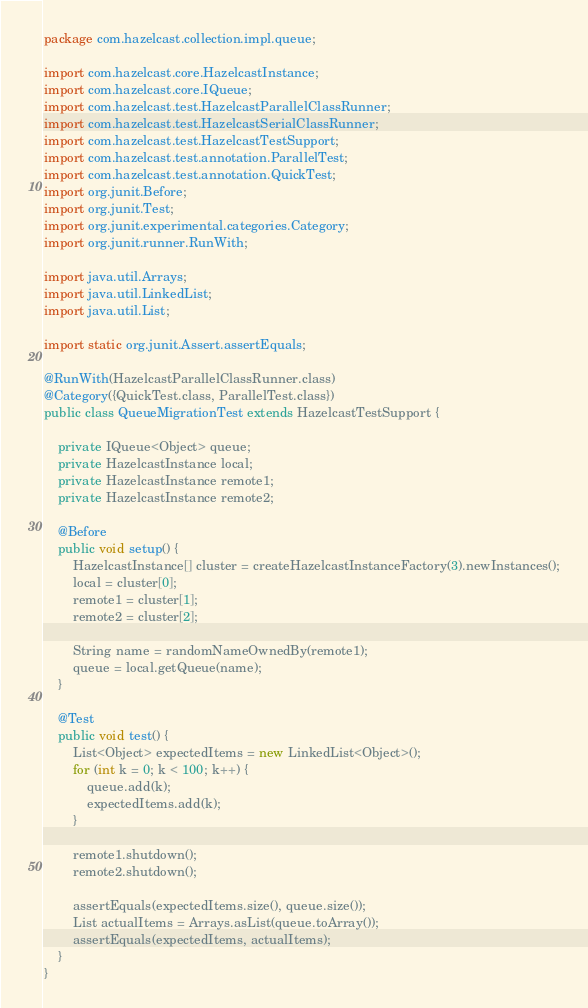Convert code to text. <code><loc_0><loc_0><loc_500><loc_500><_Java_>package com.hazelcast.collection.impl.queue;

import com.hazelcast.core.HazelcastInstance;
import com.hazelcast.core.IQueue;
import com.hazelcast.test.HazelcastParallelClassRunner;
import com.hazelcast.test.HazelcastSerialClassRunner;
import com.hazelcast.test.HazelcastTestSupport;
import com.hazelcast.test.annotation.ParallelTest;
import com.hazelcast.test.annotation.QuickTest;
import org.junit.Before;
import org.junit.Test;
import org.junit.experimental.categories.Category;
import org.junit.runner.RunWith;

import java.util.Arrays;
import java.util.LinkedList;
import java.util.List;

import static org.junit.Assert.assertEquals;

@RunWith(HazelcastParallelClassRunner.class)
@Category({QuickTest.class, ParallelTest.class})
public class QueueMigrationTest extends HazelcastTestSupport {

    private IQueue<Object> queue;
    private HazelcastInstance local;
    private HazelcastInstance remote1;
    private HazelcastInstance remote2;

    @Before
    public void setup() {
        HazelcastInstance[] cluster = createHazelcastInstanceFactory(3).newInstances();
        local = cluster[0];
        remote1 = cluster[1];
        remote2 = cluster[2];

        String name = randomNameOwnedBy(remote1);
        queue = local.getQueue(name);
    }

    @Test
    public void test() {
        List<Object> expectedItems = new LinkedList<Object>();
        for (int k = 0; k < 100; k++) {
            queue.add(k);
            expectedItems.add(k);
        }

        remote1.shutdown();
        remote2.shutdown();

        assertEquals(expectedItems.size(), queue.size());
        List actualItems = Arrays.asList(queue.toArray());
        assertEquals(expectedItems, actualItems);
    }
}
</code> 